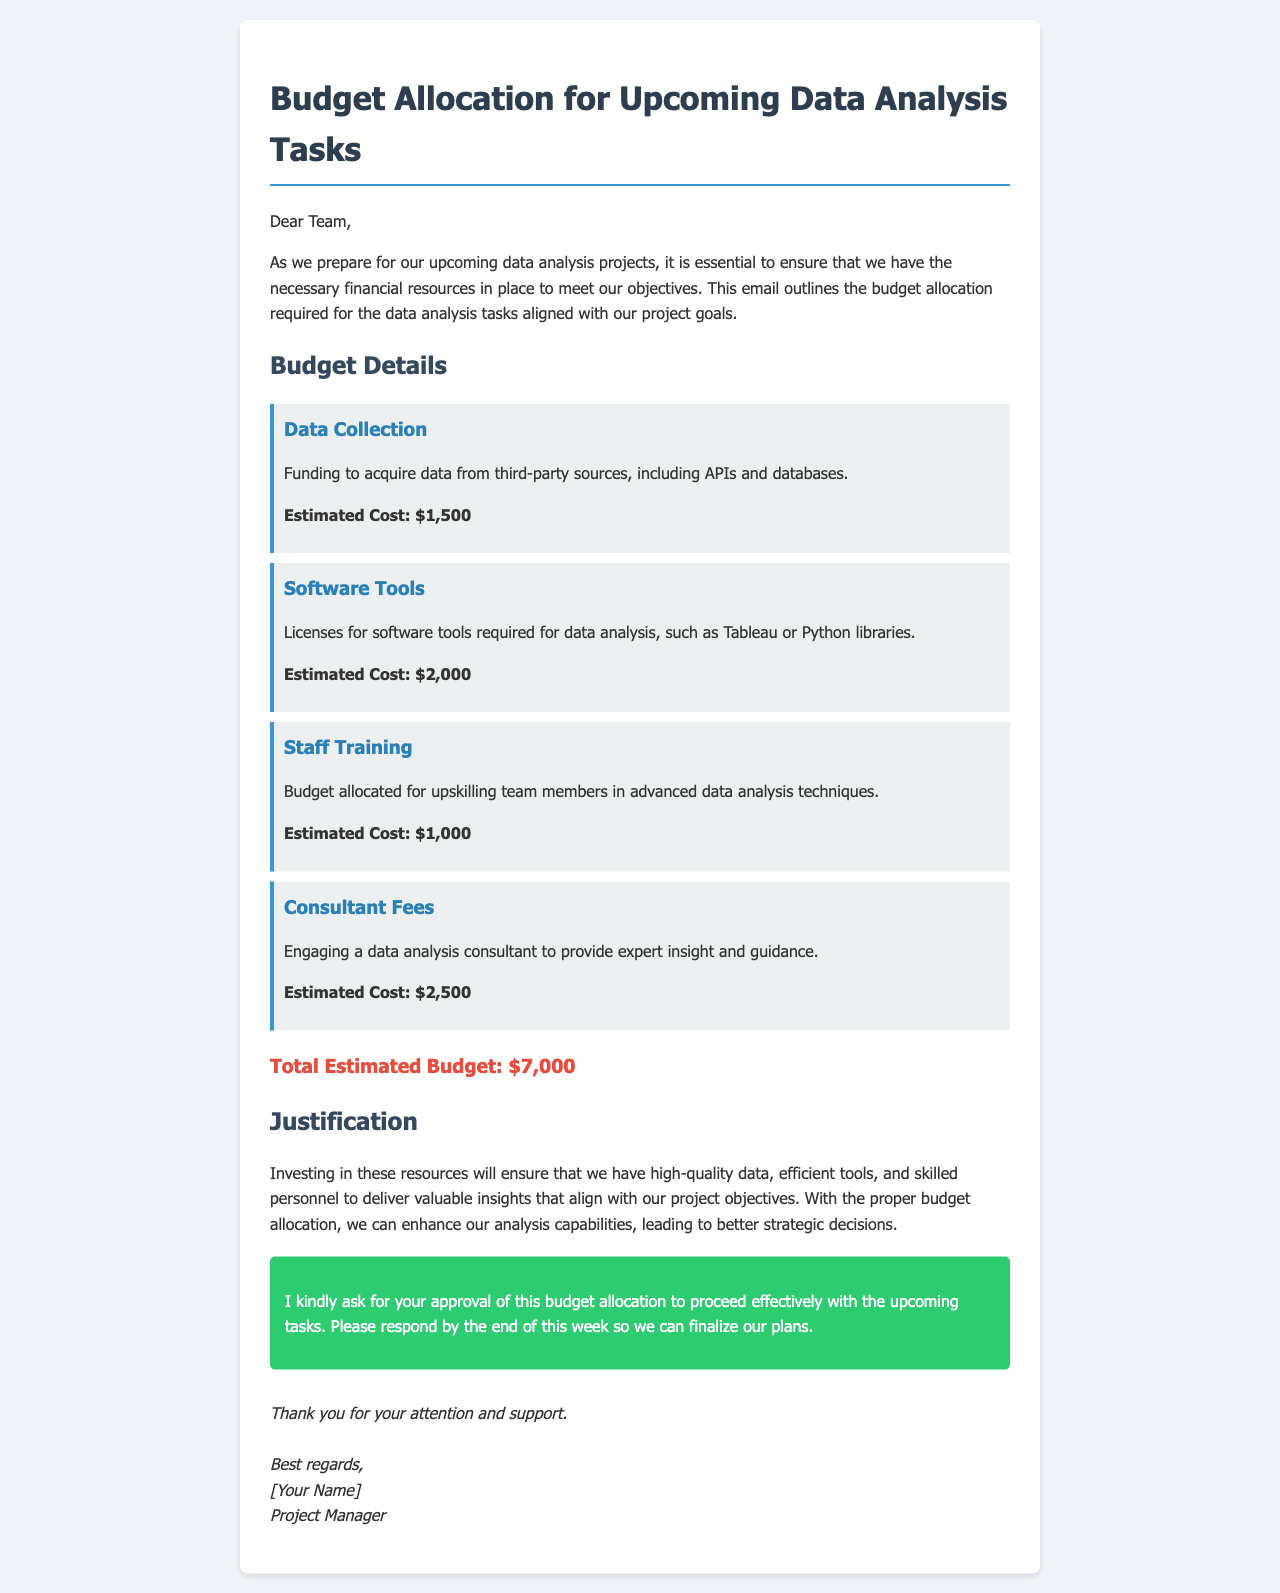what is the total estimated budget? The total estimated budget is presented as a single figure in the document summing all costs outlined.
Answer: $7,000 how much is allocated for Data Collection? The document specifies an estimated cost associated with Data Collection.
Answer: $1,500 what is the purpose of the Consultant Fees? The document states this budget is for engaging a consultant for expert insight and guidance.
Answer: expert insight and guidance how much is budgeted for Software Tools? The estimated cost for Software Tools is listed explicitly in the budget section.
Answer: $2,000 what training is included in the budget? The document details that the budget includes training for upskilling team members.
Answer: upskilling team members why is staff training necessary according to the document? The document states that staff training is essential for enhancing advanced data analysis techniques.
Answer: advanced data analysis techniques what action is requested at the end of the email? The document specifies a request for approval regarding the budget allocation.
Answer: approval what is the deadline for the approval response? The document indicates a specific timeline for the response at the end of the week.
Answer: end of this week who is the sender of the email? The sender's name is mentioned in the signature section of the document.
Answer: [Your Name] 